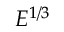Convert formula to latex. <formula><loc_0><loc_0><loc_500><loc_500>E ^ { 1 / 3 }</formula> 